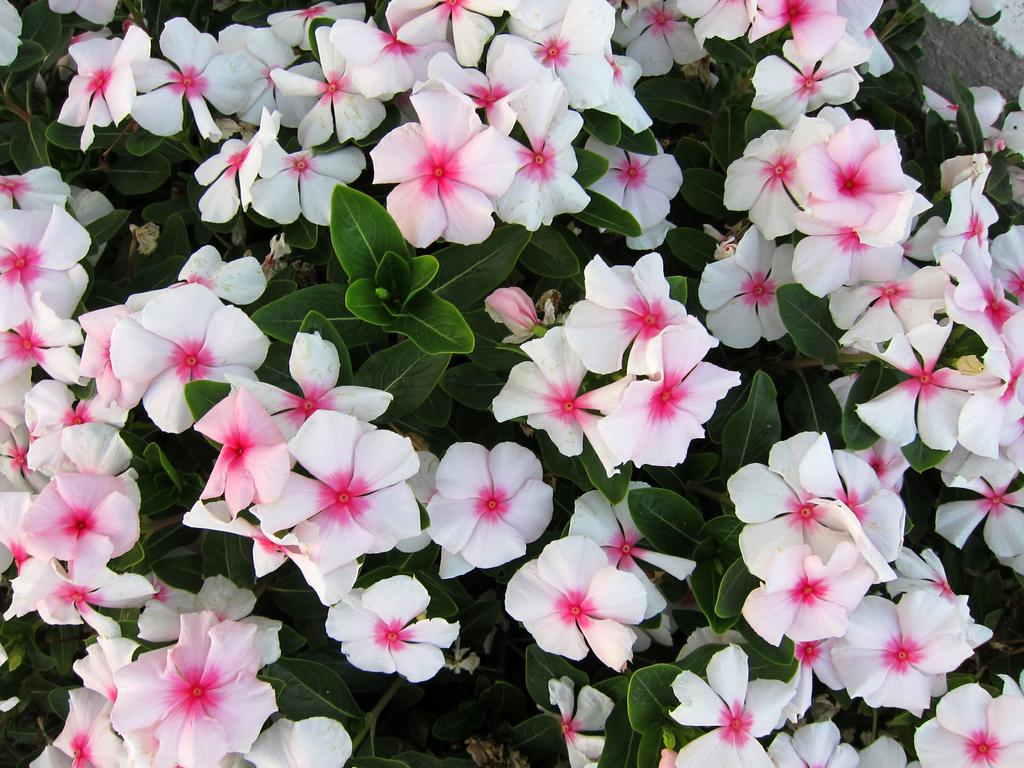What color are the flowers in the image? The flowers in the image are white. What type of plant do the flowers belong to? The flowers are part of a plant. What color are the leaves of the plant? The leaves of the plant are green. What type of humor can be found in the letters on the calendar in the image? There are no letters or calendar present in the image, so it is not possible to determine the type of humor in the letters. 